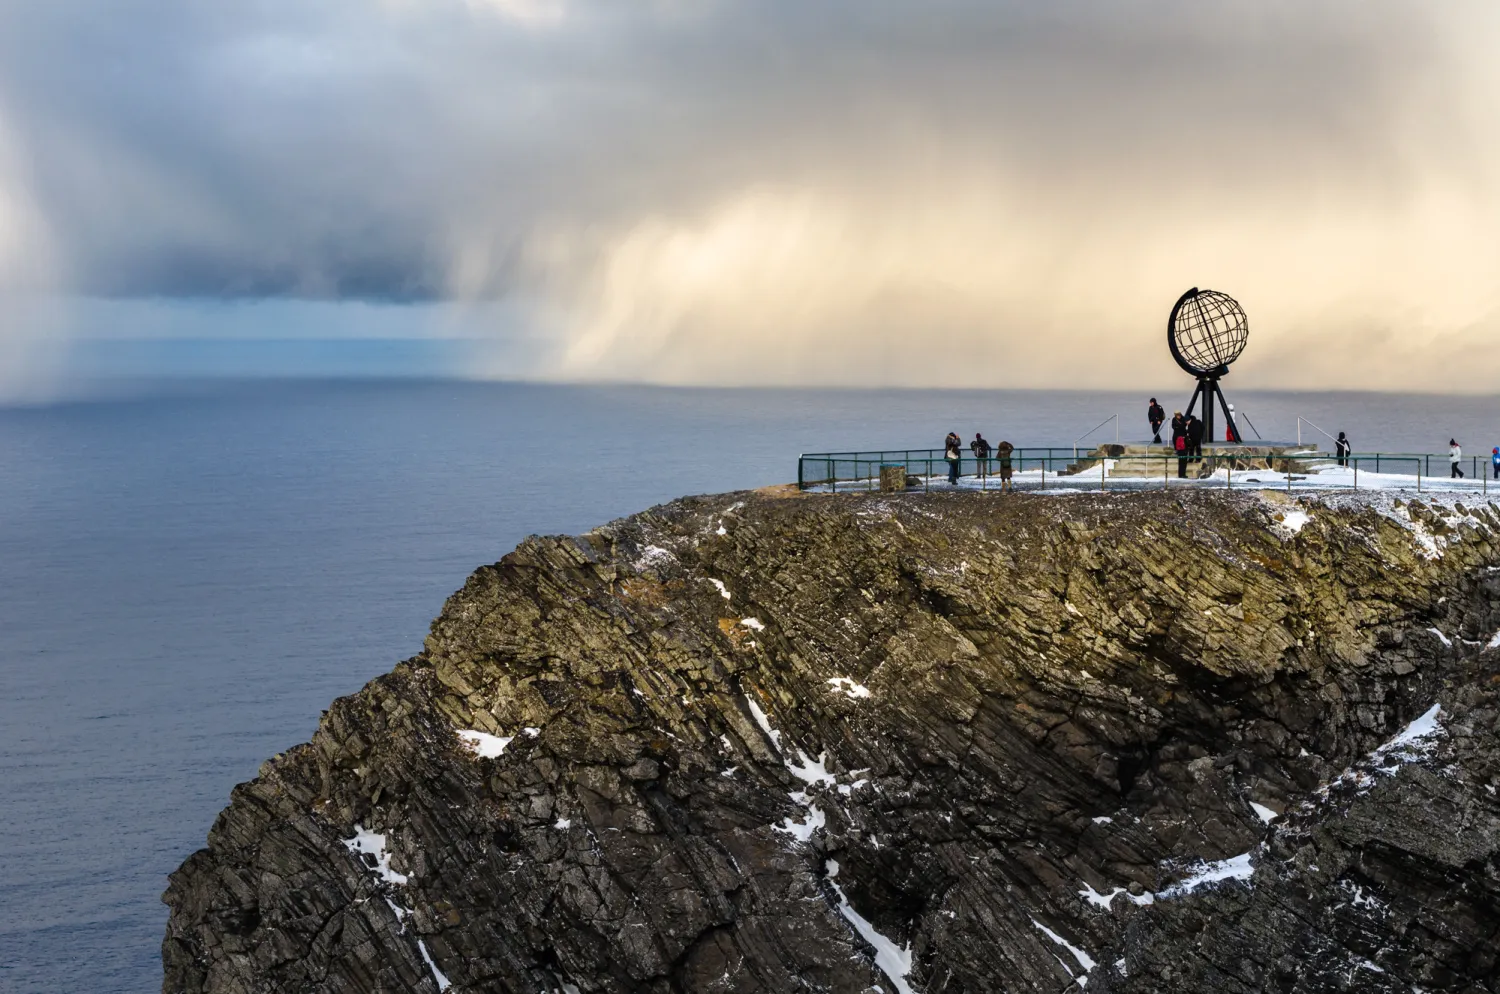How does the weather affect the experience of visiting this place? The weather at North Cape is characterized by variability and extreme conditions, which significantly shape the visitor experience. The frequent strong winds, snow, and rapid changes in weather can make the landscape appear more dramatic and awe-inspiring but might also pose challenges for visitors. The interaction of sunlight with clouds, as seen in the image, can create breathtaking views, enhancing the mystical appeal of the cape. 